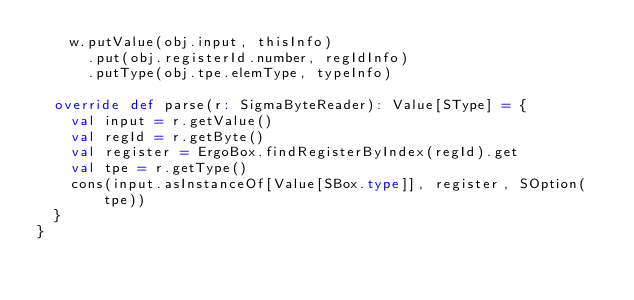<code> <loc_0><loc_0><loc_500><loc_500><_Scala_>    w.putValue(obj.input, thisInfo)
      .put(obj.registerId.number, regIdInfo)
      .putType(obj.tpe.elemType, typeInfo)

  override def parse(r: SigmaByteReader): Value[SType] = {
    val input = r.getValue()
    val regId = r.getByte()
    val register = ErgoBox.findRegisterByIndex(regId).get
    val tpe = r.getType()
    cons(input.asInstanceOf[Value[SBox.type]], register, SOption(tpe))
  }
}
</code> 